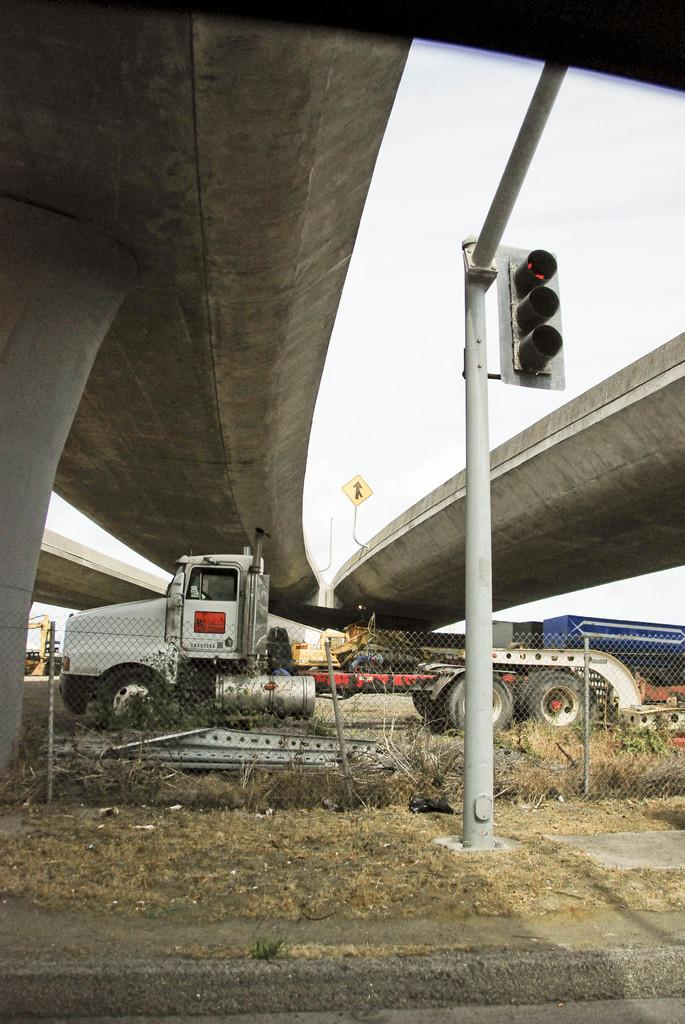What is the main subject of the image? There is a vehicle in the image. How is the vehicle positioned in the image? The vehicle is on a board. What other structures can be seen in the image? There is a fence, a bridge, and poles in the image. What traffic control device is present in the image? There is a traffic signal in the image. What can be seen in the background of the image? The sky is visible in the background of the image. Can you tell me how the vehicle is jumping over the river in the image? There is no river present in the image, and the vehicle is not shown jumping. 